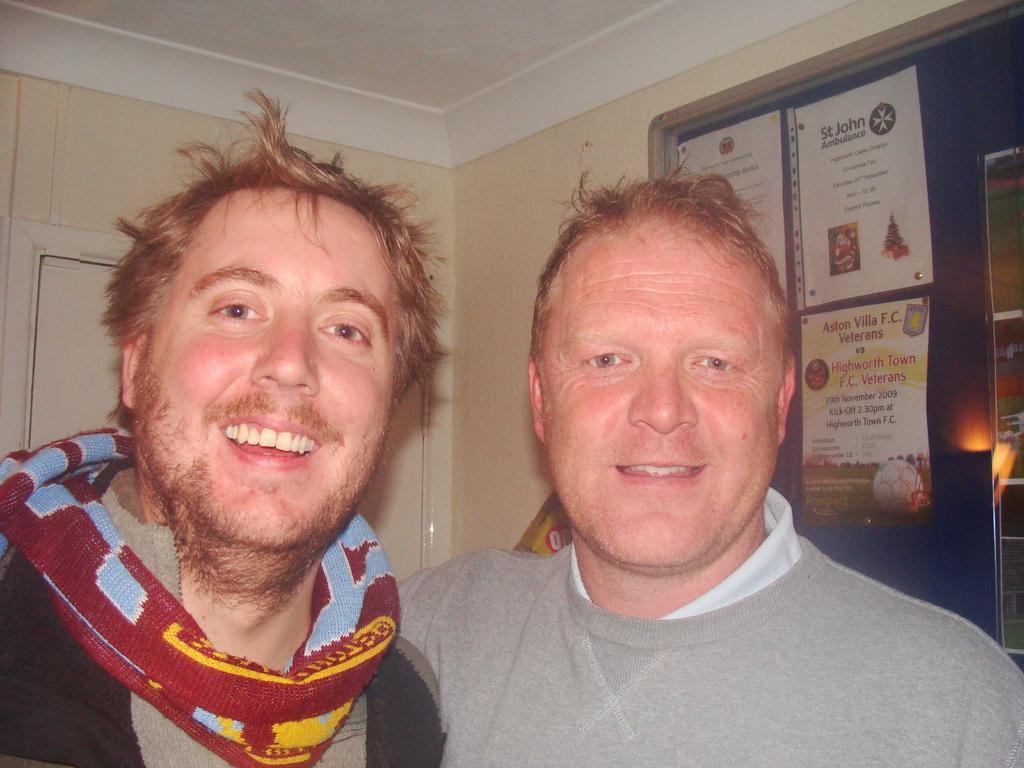Describe this image in one or two sentences. In the image I can see two people are standing and smiling. On the right side of the image I can see some written text on the board. 